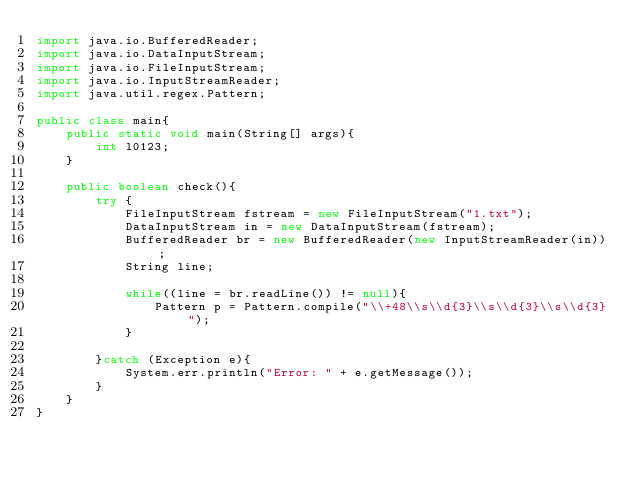<code> <loc_0><loc_0><loc_500><loc_500><_Java_>import java.io.BufferedReader;
import java.io.DataInputStream;
import java.io.FileInputStream;
import java.io.InputStreamReader;
import java.util.regex.Pattern;

public class main{
    public static void main(String[] args){
        int l0123;
    }

    public boolean check(){
        try {
            FileInputStream fstream = new FileInputStream("1.txt");
            DataInputStream in = new DataInputStream(fstream);
            BufferedReader br = new BufferedReader(new InputStreamReader(in));
            String line;

            while((line = br.readLine()) != null){
                Pattern p = Pattern.compile("\\+48\\s\\d{3}\\s\\d{3}\\s\\d{3}");
            }

        }catch (Exception e){
            System.err.println("Error: " + e.getMessage());
        }
    }
}</code> 